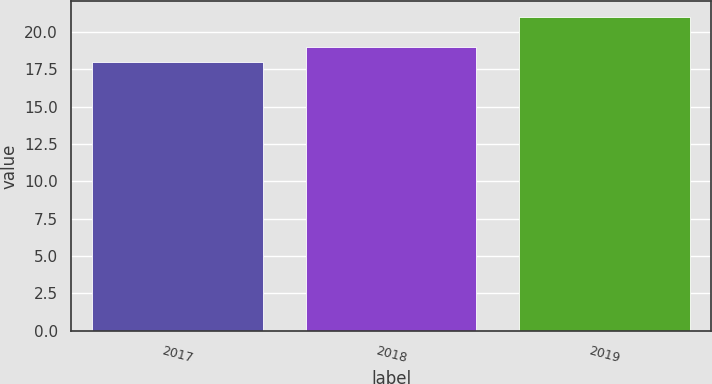<chart> <loc_0><loc_0><loc_500><loc_500><bar_chart><fcel>2017<fcel>2018<fcel>2019<nl><fcel>18<fcel>19<fcel>21<nl></chart> 